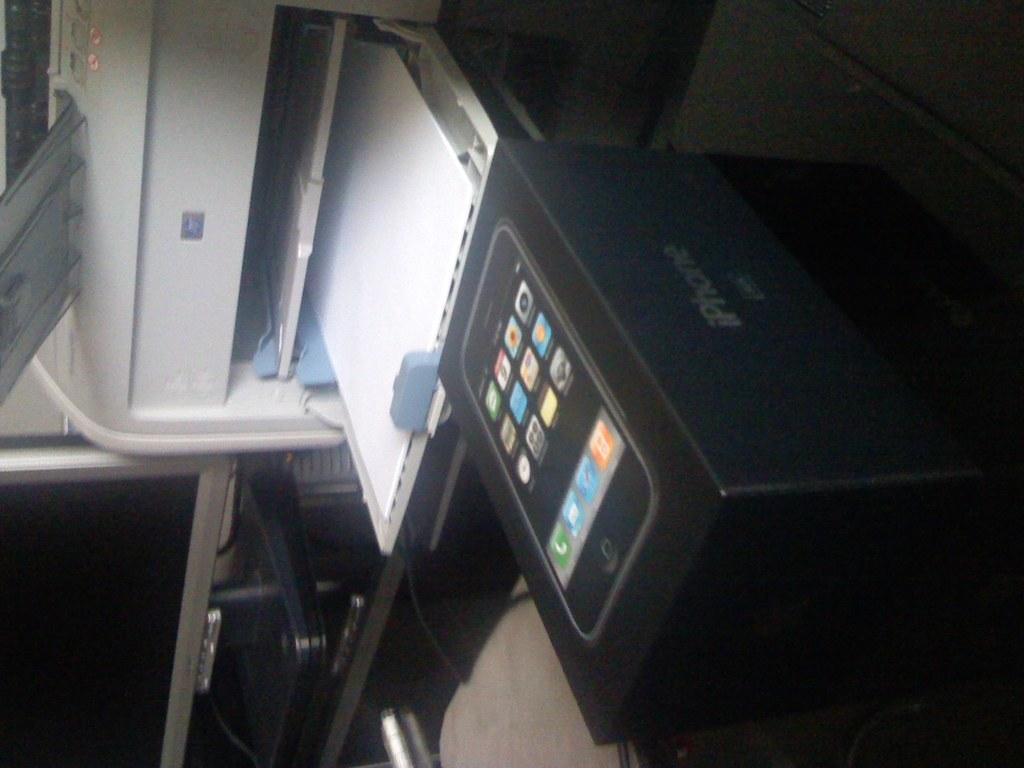Provide a one-sentence caption for the provided image. A Iphone box that is in front of a printer. 